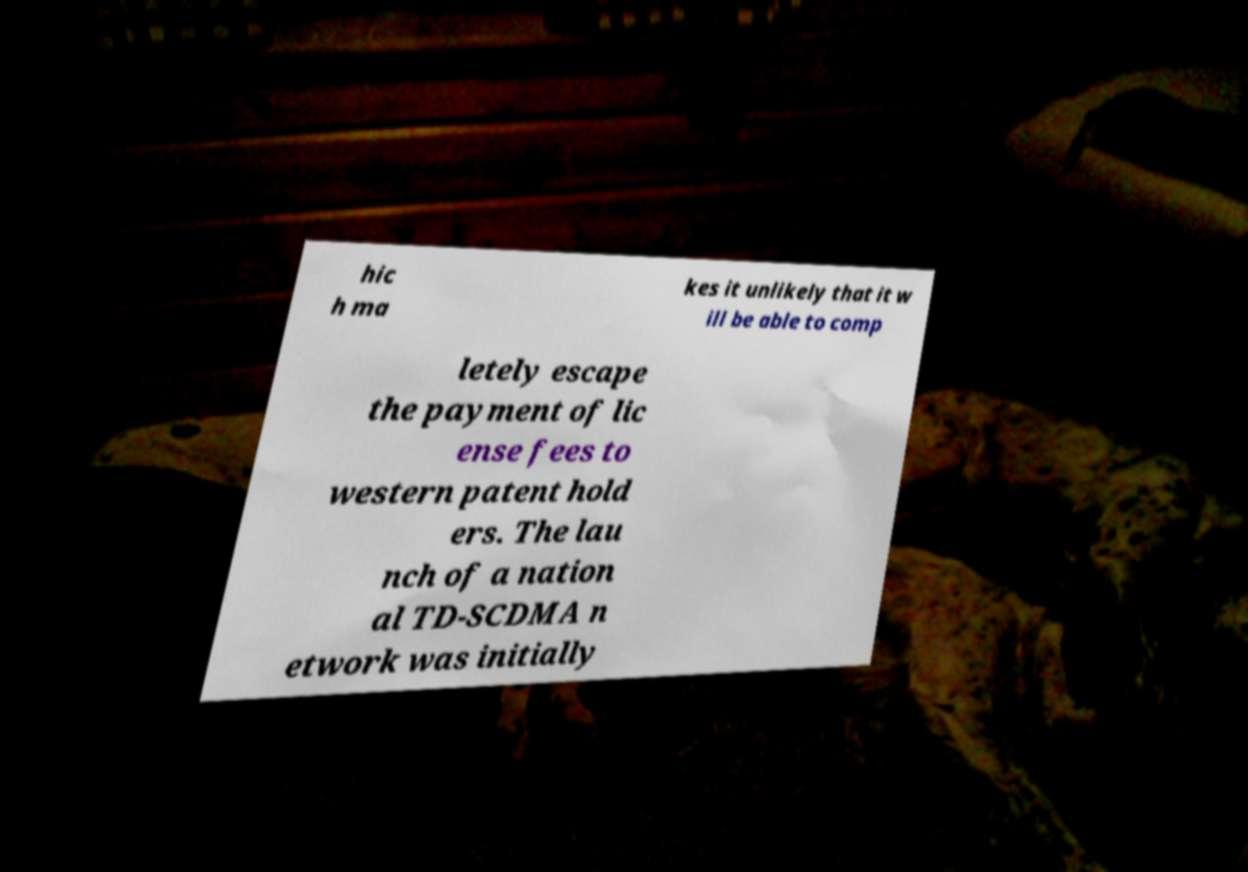There's text embedded in this image that I need extracted. Can you transcribe it verbatim? hic h ma kes it unlikely that it w ill be able to comp letely escape the payment of lic ense fees to western patent hold ers. The lau nch of a nation al TD-SCDMA n etwork was initially 